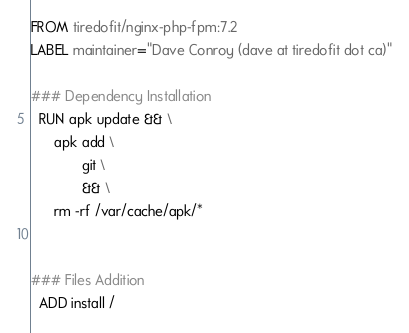<code> <loc_0><loc_0><loc_500><loc_500><_Dockerfile_>FROM tiredofit/nginx-php-fpm:7.2
LABEL maintainer="Dave Conroy (dave at tiredofit dot ca)"

### Dependency Installation
  RUN apk update && \
      apk add \
             git \
             && \
      rm -rf /var/cache/apk/*


### Files Addition
  ADD install /
</code> 